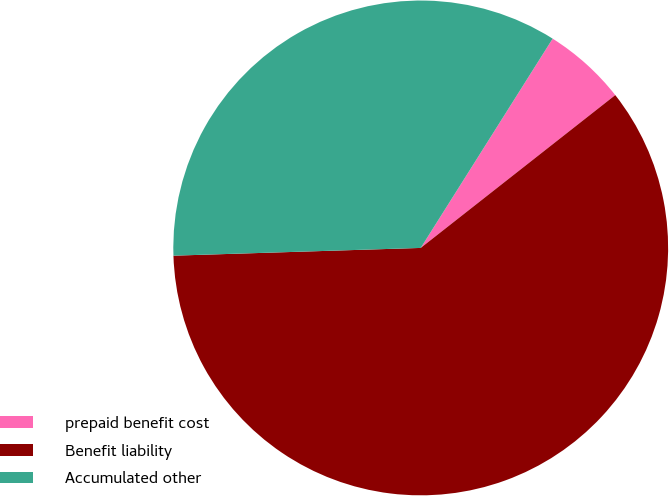Convert chart. <chart><loc_0><loc_0><loc_500><loc_500><pie_chart><fcel>prepaid benefit cost<fcel>Benefit liability<fcel>Accumulated other<nl><fcel>5.45%<fcel>60.1%<fcel>34.45%<nl></chart> 